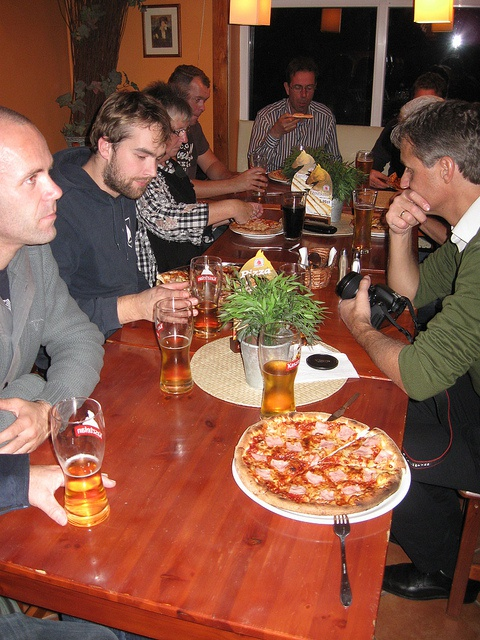Describe the objects in this image and their specific colors. I can see dining table in maroon, brown, and red tones, people in maroon, black, gray, darkgreen, and brown tones, people in maroon, gray, lightpink, and pink tones, people in maroon, gray, black, and salmon tones, and dining table in maroon, black, and brown tones in this image. 